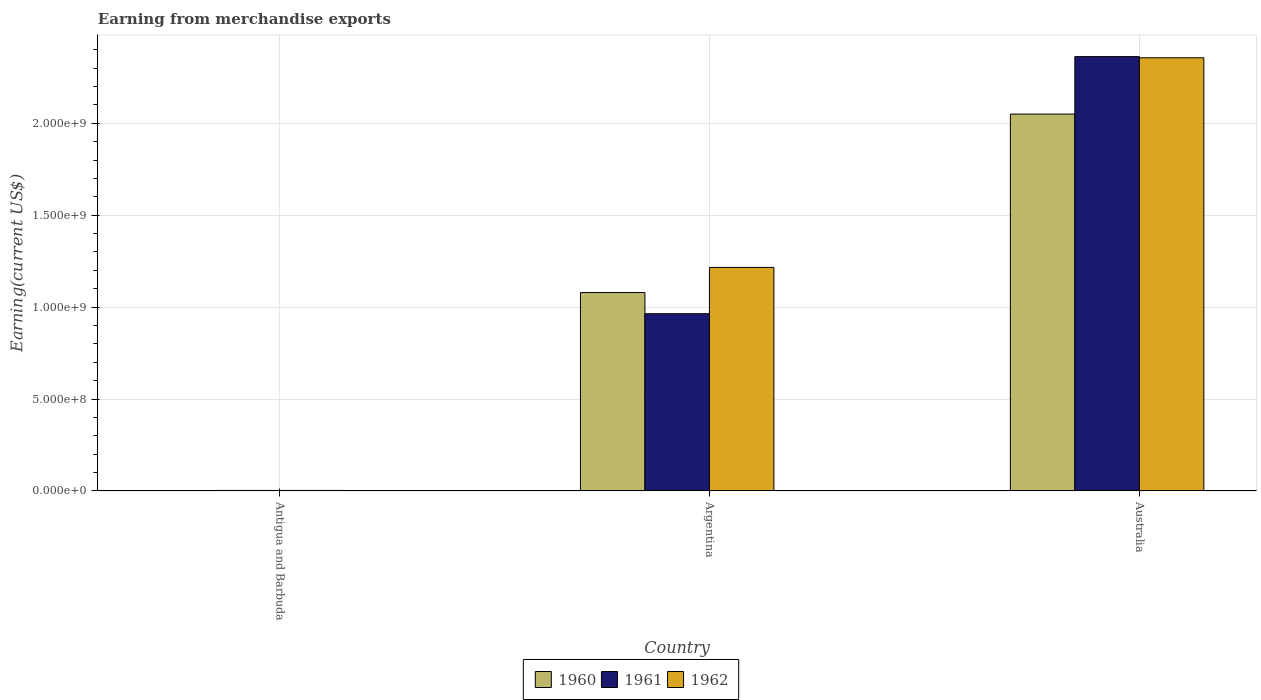How many groups of bars are there?
Your response must be concise. 3. Are the number of bars on each tick of the X-axis equal?
Your answer should be very brief. Yes. How many bars are there on the 3rd tick from the left?
Your answer should be compact. 3. What is the label of the 3rd group of bars from the left?
Give a very brief answer. Australia. In how many cases, is the number of bars for a given country not equal to the number of legend labels?
Provide a short and direct response. 0. What is the amount earned from merchandise exports in 1960 in Australia?
Offer a terse response. 2.05e+09. Across all countries, what is the maximum amount earned from merchandise exports in 1962?
Your answer should be compact. 2.36e+09. In which country was the amount earned from merchandise exports in 1960 minimum?
Your answer should be compact. Antigua and Barbuda. What is the total amount earned from merchandise exports in 1960 in the graph?
Provide a short and direct response. 3.13e+09. What is the difference between the amount earned from merchandise exports in 1962 in Antigua and Barbuda and that in Argentina?
Offer a very short reply. -1.21e+09. What is the difference between the amount earned from merchandise exports in 1961 in Argentina and the amount earned from merchandise exports in 1962 in Antigua and Barbuda?
Offer a very short reply. 9.61e+08. What is the average amount earned from merchandise exports in 1961 per country?
Your answer should be very brief. 1.11e+09. What is the difference between the amount earned from merchandise exports of/in 1962 and amount earned from merchandise exports of/in 1960 in Australia?
Keep it short and to the point. 3.06e+08. In how many countries, is the amount earned from merchandise exports in 1961 greater than 2000000000 US$?
Provide a succinct answer. 1. What is the ratio of the amount earned from merchandise exports in 1961 in Antigua and Barbuda to that in Australia?
Your answer should be compact. 0. What is the difference between the highest and the second highest amount earned from merchandise exports in 1961?
Make the answer very short. 1.40e+09. What is the difference between the highest and the lowest amount earned from merchandise exports in 1961?
Your response must be concise. 2.36e+09. What does the 2nd bar from the left in Argentina represents?
Keep it short and to the point. 1961. Is it the case that in every country, the sum of the amount earned from merchandise exports in 1962 and amount earned from merchandise exports in 1960 is greater than the amount earned from merchandise exports in 1961?
Your response must be concise. Yes. How many bars are there?
Give a very brief answer. 9. Are all the bars in the graph horizontal?
Provide a succinct answer. No. What is the difference between two consecutive major ticks on the Y-axis?
Your response must be concise. 5.00e+08. Are the values on the major ticks of Y-axis written in scientific E-notation?
Keep it short and to the point. Yes. Does the graph contain any zero values?
Give a very brief answer. No. Does the graph contain grids?
Give a very brief answer. Yes. Where does the legend appear in the graph?
Provide a succinct answer. Bottom center. How many legend labels are there?
Your answer should be compact. 3. What is the title of the graph?
Provide a succinct answer. Earning from merchandise exports. What is the label or title of the X-axis?
Your response must be concise. Country. What is the label or title of the Y-axis?
Give a very brief answer. Earning(current US$). What is the Earning(current US$) of 1960 in Antigua and Barbuda?
Your answer should be compact. 2.00e+06. What is the Earning(current US$) in 1960 in Argentina?
Your answer should be compact. 1.08e+09. What is the Earning(current US$) of 1961 in Argentina?
Provide a short and direct response. 9.64e+08. What is the Earning(current US$) in 1962 in Argentina?
Ensure brevity in your answer.  1.22e+09. What is the Earning(current US$) in 1960 in Australia?
Offer a very short reply. 2.05e+09. What is the Earning(current US$) of 1961 in Australia?
Offer a terse response. 2.36e+09. What is the Earning(current US$) in 1962 in Australia?
Your answer should be compact. 2.36e+09. Across all countries, what is the maximum Earning(current US$) of 1960?
Offer a terse response. 2.05e+09. Across all countries, what is the maximum Earning(current US$) in 1961?
Ensure brevity in your answer.  2.36e+09. Across all countries, what is the maximum Earning(current US$) of 1962?
Make the answer very short. 2.36e+09. Across all countries, what is the minimum Earning(current US$) in 1962?
Offer a very short reply. 3.00e+06. What is the total Earning(current US$) in 1960 in the graph?
Provide a succinct answer. 3.13e+09. What is the total Earning(current US$) in 1961 in the graph?
Offer a terse response. 3.33e+09. What is the total Earning(current US$) in 1962 in the graph?
Keep it short and to the point. 3.58e+09. What is the difference between the Earning(current US$) of 1960 in Antigua and Barbuda and that in Argentina?
Offer a terse response. -1.08e+09. What is the difference between the Earning(current US$) of 1961 in Antigua and Barbuda and that in Argentina?
Your answer should be very brief. -9.61e+08. What is the difference between the Earning(current US$) in 1962 in Antigua and Barbuda and that in Argentina?
Your answer should be very brief. -1.21e+09. What is the difference between the Earning(current US$) of 1960 in Antigua and Barbuda and that in Australia?
Your response must be concise. -2.05e+09. What is the difference between the Earning(current US$) of 1961 in Antigua and Barbuda and that in Australia?
Give a very brief answer. -2.36e+09. What is the difference between the Earning(current US$) of 1962 in Antigua and Barbuda and that in Australia?
Your answer should be compact. -2.35e+09. What is the difference between the Earning(current US$) of 1960 in Argentina and that in Australia?
Offer a terse response. -9.71e+08. What is the difference between the Earning(current US$) in 1961 in Argentina and that in Australia?
Offer a terse response. -1.40e+09. What is the difference between the Earning(current US$) in 1962 in Argentina and that in Australia?
Keep it short and to the point. -1.14e+09. What is the difference between the Earning(current US$) in 1960 in Antigua and Barbuda and the Earning(current US$) in 1961 in Argentina?
Make the answer very short. -9.62e+08. What is the difference between the Earning(current US$) of 1960 in Antigua and Barbuda and the Earning(current US$) of 1962 in Argentina?
Give a very brief answer. -1.21e+09. What is the difference between the Earning(current US$) of 1961 in Antigua and Barbuda and the Earning(current US$) of 1962 in Argentina?
Make the answer very short. -1.21e+09. What is the difference between the Earning(current US$) of 1960 in Antigua and Barbuda and the Earning(current US$) of 1961 in Australia?
Your answer should be very brief. -2.36e+09. What is the difference between the Earning(current US$) in 1960 in Antigua and Barbuda and the Earning(current US$) in 1962 in Australia?
Offer a terse response. -2.35e+09. What is the difference between the Earning(current US$) of 1961 in Antigua and Barbuda and the Earning(current US$) of 1962 in Australia?
Give a very brief answer. -2.35e+09. What is the difference between the Earning(current US$) of 1960 in Argentina and the Earning(current US$) of 1961 in Australia?
Offer a terse response. -1.28e+09. What is the difference between the Earning(current US$) in 1960 in Argentina and the Earning(current US$) in 1962 in Australia?
Provide a succinct answer. -1.28e+09. What is the difference between the Earning(current US$) in 1961 in Argentina and the Earning(current US$) in 1962 in Australia?
Offer a very short reply. -1.39e+09. What is the average Earning(current US$) in 1960 per country?
Give a very brief answer. 1.04e+09. What is the average Earning(current US$) of 1961 per country?
Offer a terse response. 1.11e+09. What is the average Earning(current US$) in 1962 per country?
Provide a short and direct response. 1.19e+09. What is the difference between the Earning(current US$) of 1960 and Earning(current US$) of 1961 in Antigua and Barbuda?
Provide a succinct answer. -1.00e+06. What is the difference between the Earning(current US$) of 1960 and Earning(current US$) of 1962 in Antigua and Barbuda?
Provide a short and direct response. -1.00e+06. What is the difference between the Earning(current US$) in 1961 and Earning(current US$) in 1962 in Antigua and Barbuda?
Provide a short and direct response. 0. What is the difference between the Earning(current US$) in 1960 and Earning(current US$) in 1961 in Argentina?
Make the answer very short. 1.15e+08. What is the difference between the Earning(current US$) in 1960 and Earning(current US$) in 1962 in Argentina?
Give a very brief answer. -1.37e+08. What is the difference between the Earning(current US$) of 1961 and Earning(current US$) of 1962 in Argentina?
Your answer should be compact. -2.52e+08. What is the difference between the Earning(current US$) in 1960 and Earning(current US$) in 1961 in Australia?
Ensure brevity in your answer.  -3.13e+08. What is the difference between the Earning(current US$) in 1960 and Earning(current US$) in 1962 in Australia?
Make the answer very short. -3.06e+08. What is the difference between the Earning(current US$) in 1961 and Earning(current US$) in 1962 in Australia?
Your answer should be very brief. 6.39e+06. What is the ratio of the Earning(current US$) of 1960 in Antigua and Barbuda to that in Argentina?
Provide a short and direct response. 0. What is the ratio of the Earning(current US$) of 1961 in Antigua and Barbuda to that in Argentina?
Make the answer very short. 0. What is the ratio of the Earning(current US$) in 1962 in Antigua and Barbuda to that in Argentina?
Provide a short and direct response. 0. What is the ratio of the Earning(current US$) in 1961 in Antigua and Barbuda to that in Australia?
Your answer should be very brief. 0. What is the ratio of the Earning(current US$) of 1962 in Antigua and Barbuda to that in Australia?
Your answer should be compact. 0. What is the ratio of the Earning(current US$) of 1960 in Argentina to that in Australia?
Offer a very short reply. 0.53. What is the ratio of the Earning(current US$) in 1961 in Argentina to that in Australia?
Your answer should be compact. 0.41. What is the ratio of the Earning(current US$) in 1962 in Argentina to that in Australia?
Provide a succinct answer. 0.52. What is the difference between the highest and the second highest Earning(current US$) of 1960?
Keep it short and to the point. 9.71e+08. What is the difference between the highest and the second highest Earning(current US$) of 1961?
Give a very brief answer. 1.40e+09. What is the difference between the highest and the second highest Earning(current US$) of 1962?
Your response must be concise. 1.14e+09. What is the difference between the highest and the lowest Earning(current US$) in 1960?
Offer a terse response. 2.05e+09. What is the difference between the highest and the lowest Earning(current US$) in 1961?
Provide a succinct answer. 2.36e+09. What is the difference between the highest and the lowest Earning(current US$) in 1962?
Provide a succinct answer. 2.35e+09. 